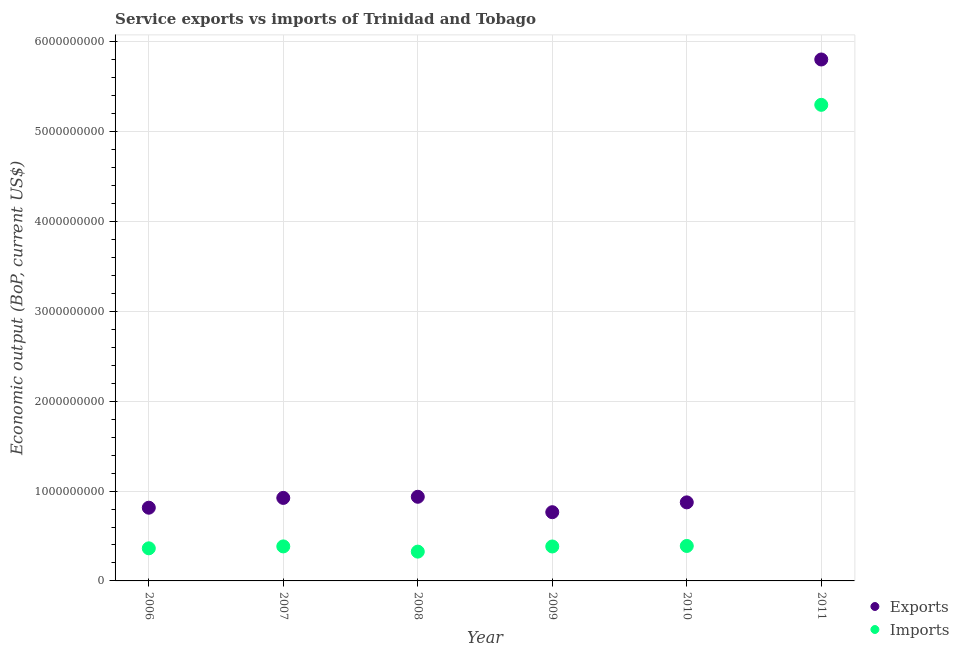How many different coloured dotlines are there?
Give a very brief answer. 2. Is the number of dotlines equal to the number of legend labels?
Provide a short and direct response. Yes. What is the amount of service imports in 2009?
Offer a terse response. 3.83e+08. Across all years, what is the maximum amount of service imports?
Your answer should be compact. 5.30e+09. Across all years, what is the minimum amount of service imports?
Your answer should be compact. 3.26e+08. In which year was the amount of service exports maximum?
Keep it short and to the point. 2011. What is the total amount of service exports in the graph?
Provide a succinct answer. 1.01e+1. What is the difference between the amount of service exports in 2006 and that in 2011?
Offer a terse response. -4.99e+09. What is the difference between the amount of service exports in 2011 and the amount of service imports in 2010?
Ensure brevity in your answer.  5.41e+09. What is the average amount of service exports per year?
Provide a short and direct response. 1.69e+09. In the year 2010, what is the difference between the amount of service imports and amount of service exports?
Your answer should be compact. -4.85e+08. In how many years, is the amount of service exports greater than 5000000000 US$?
Make the answer very short. 1. What is the ratio of the amount of service exports in 2006 to that in 2007?
Offer a very short reply. 0.88. Is the difference between the amount of service exports in 2008 and 2010 greater than the difference between the amount of service imports in 2008 and 2010?
Provide a succinct answer. Yes. What is the difference between the highest and the second highest amount of service exports?
Provide a succinct answer. 4.87e+09. What is the difference between the highest and the lowest amount of service imports?
Your answer should be compact. 4.97e+09. In how many years, is the amount of service imports greater than the average amount of service imports taken over all years?
Your answer should be very brief. 1. Is the sum of the amount of service imports in 2006 and 2008 greater than the maximum amount of service exports across all years?
Your answer should be very brief. No. Does the amount of service exports monotonically increase over the years?
Ensure brevity in your answer.  No. Is the amount of service imports strictly greater than the amount of service exports over the years?
Make the answer very short. No. Is the amount of service imports strictly less than the amount of service exports over the years?
Ensure brevity in your answer.  Yes. How many dotlines are there?
Provide a succinct answer. 2. How many years are there in the graph?
Provide a succinct answer. 6. Does the graph contain any zero values?
Offer a terse response. No. How many legend labels are there?
Your answer should be compact. 2. What is the title of the graph?
Your answer should be very brief. Service exports vs imports of Trinidad and Tobago. What is the label or title of the Y-axis?
Ensure brevity in your answer.  Economic output (BoP, current US$). What is the Economic output (BoP, current US$) in Exports in 2006?
Offer a terse response. 8.15e+08. What is the Economic output (BoP, current US$) in Imports in 2006?
Provide a short and direct response. 3.63e+08. What is the Economic output (BoP, current US$) in Exports in 2007?
Your answer should be compact. 9.24e+08. What is the Economic output (BoP, current US$) of Imports in 2007?
Keep it short and to the point. 3.84e+08. What is the Economic output (BoP, current US$) in Exports in 2008?
Provide a short and direct response. 9.36e+08. What is the Economic output (BoP, current US$) of Imports in 2008?
Ensure brevity in your answer.  3.26e+08. What is the Economic output (BoP, current US$) of Exports in 2009?
Give a very brief answer. 7.65e+08. What is the Economic output (BoP, current US$) of Imports in 2009?
Make the answer very short. 3.83e+08. What is the Economic output (BoP, current US$) in Exports in 2010?
Your answer should be compact. 8.74e+08. What is the Economic output (BoP, current US$) in Imports in 2010?
Your response must be concise. 3.89e+08. What is the Economic output (BoP, current US$) of Exports in 2011?
Make the answer very short. 5.80e+09. What is the Economic output (BoP, current US$) of Imports in 2011?
Offer a terse response. 5.30e+09. Across all years, what is the maximum Economic output (BoP, current US$) in Exports?
Give a very brief answer. 5.80e+09. Across all years, what is the maximum Economic output (BoP, current US$) in Imports?
Your answer should be very brief. 5.30e+09. Across all years, what is the minimum Economic output (BoP, current US$) in Exports?
Your response must be concise. 7.65e+08. Across all years, what is the minimum Economic output (BoP, current US$) in Imports?
Your answer should be compact. 3.26e+08. What is the total Economic output (BoP, current US$) in Exports in the graph?
Your response must be concise. 1.01e+1. What is the total Economic output (BoP, current US$) in Imports in the graph?
Offer a terse response. 7.14e+09. What is the difference between the Economic output (BoP, current US$) in Exports in 2006 and that in 2007?
Make the answer very short. -1.09e+08. What is the difference between the Economic output (BoP, current US$) in Imports in 2006 and that in 2007?
Offer a terse response. -2.13e+07. What is the difference between the Economic output (BoP, current US$) in Exports in 2006 and that in 2008?
Your answer should be very brief. -1.22e+08. What is the difference between the Economic output (BoP, current US$) of Imports in 2006 and that in 2008?
Your answer should be very brief. 3.68e+07. What is the difference between the Economic output (BoP, current US$) in Exports in 2006 and that in 2009?
Ensure brevity in your answer.  5.00e+07. What is the difference between the Economic output (BoP, current US$) of Imports in 2006 and that in 2009?
Your answer should be very brief. -2.05e+07. What is the difference between the Economic output (BoP, current US$) of Exports in 2006 and that in 2010?
Provide a succinct answer. -5.94e+07. What is the difference between the Economic output (BoP, current US$) in Imports in 2006 and that in 2010?
Ensure brevity in your answer.  -2.63e+07. What is the difference between the Economic output (BoP, current US$) of Exports in 2006 and that in 2011?
Give a very brief answer. -4.99e+09. What is the difference between the Economic output (BoP, current US$) in Imports in 2006 and that in 2011?
Ensure brevity in your answer.  -4.94e+09. What is the difference between the Economic output (BoP, current US$) of Exports in 2007 and that in 2008?
Give a very brief answer. -1.27e+07. What is the difference between the Economic output (BoP, current US$) of Imports in 2007 and that in 2008?
Offer a very short reply. 5.81e+07. What is the difference between the Economic output (BoP, current US$) of Exports in 2007 and that in 2009?
Provide a short and direct response. 1.59e+08. What is the difference between the Economic output (BoP, current US$) in Exports in 2007 and that in 2010?
Offer a terse response. 4.96e+07. What is the difference between the Economic output (BoP, current US$) in Imports in 2007 and that in 2010?
Give a very brief answer. -5.00e+06. What is the difference between the Economic output (BoP, current US$) in Exports in 2007 and that in 2011?
Keep it short and to the point. -4.88e+09. What is the difference between the Economic output (BoP, current US$) of Imports in 2007 and that in 2011?
Offer a terse response. -4.91e+09. What is the difference between the Economic output (BoP, current US$) of Exports in 2008 and that in 2009?
Provide a succinct answer. 1.72e+08. What is the difference between the Economic output (BoP, current US$) of Imports in 2008 and that in 2009?
Give a very brief answer. -5.73e+07. What is the difference between the Economic output (BoP, current US$) of Exports in 2008 and that in 2010?
Your answer should be compact. 6.23e+07. What is the difference between the Economic output (BoP, current US$) in Imports in 2008 and that in 2010?
Make the answer very short. -6.31e+07. What is the difference between the Economic output (BoP, current US$) in Exports in 2008 and that in 2011?
Provide a short and direct response. -4.87e+09. What is the difference between the Economic output (BoP, current US$) in Imports in 2008 and that in 2011?
Your response must be concise. -4.97e+09. What is the difference between the Economic output (BoP, current US$) of Exports in 2009 and that in 2010?
Your response must be concise. -1.09e+08. What is the difference between the Economic output (BoP, current US$) of Imports in 2009 and that in 2010?
Make the answer very short. -5.80e+06. What is the difference between the Economic output (BoP, current US$) in Exports in 2009 and that in 2011?
Give a very brief answer. -5.04e+09. What is the difference between the Economic output (BoP, current US$) of Imports in 2009 and that in 2011?
Your answer should be compact. -4.92e+09. What is the difference between the Economic output (BoP, current US$) of Exports in 2010 and that in 2011?
Your response must be concise. -4.93e+09. What is the difference between the Economic output (BoP, current US$) of Imports in 2010 and that in 2011?
Give a very brief answer. -4.91e+09. What is the difference between the Economic output (BoP, current US$) of Exports in 2006 and the Economic output (BoP, current US$) of Imports in 2007?
Provide a short and direct response. 4.31e+08. What is the difference between the Economic output (BoP, current US$) in Exports in 2006 and the Economic output (BoP, current US$) in Imports in 2008?
Provide a short and direct response. 4.89e+08. What is the difference between the Economic output (BoP, current US$) of Exports in 2006 and the Economic output (BoP, current US$) of Imports in 2009?
Your answer should be compact. 4.32e+08. What is the difference between the Economic output (BoP, current US$) in Exports in 2006 and the Economic output (BoP, current US$) in Imports in 2010?
Your response must be concise. 4.26e+08. What is the difference between the Economic output (BoP, current US$) in Exports in 2006 and the Economic output (BoP, current US$) in Imports in 2011?
Offer a very short reply. -4.48e+09. What is the difference between the Economic output (BoP, current US$) of Exports in 2007 and the Economic output (BoP, current US$) of Imports in 2008?
Offer a terse response. 5.98e+08. What is the difference between the Economic output (BoP, current US$) in Exports in 2007 and the Economic output (BoP, current US$) in Imports in 2009?
Your answer should be very brief. 5.40e+08. What is the difference between the Economic output (BoP, current US$) of Exports in 2007 and the Economic output (BoP, current US$) of Imports in 2010?
Keep it short and to the point. 5.35e+08. What is the difference between the Economic output (BoP, current US$) in Exports in 2007 and the Economic output (BoP, current US$) in Imports in 2011?
Offer a terse response. -4.37e+09. What is the difference between the Economic output (BoP, current US$) of Exports in 2008 and the Economic output (BoP, current US$) of Imports in 2009?
Offer a terse response. 5.53e+08. What is the difference between the Economic output (BoP, current US$) of Exports in 2008 and the Economic output (BoP, current US$) of Imports in 2010?
Make the answer very short. 5.47e+08. What is the difference between the Economic output (BoP, current US$) in Exports in 2008 and the Economic output (BoP, current US$) in Imports in 2011?
Ensure brevity in your answer.  -4.36e+09. What is the difference between the Economic output (BoP, current US$) of Exports in 2009 and the Economic output (BoP, current US$) of Imports in 2010?
Your answer should be very brief. 3.76e+08. What is the difference between the Economic output (BoP, current US$) of Exports in 2009 and the Economic output (BoP, current US$) of Imports in 2011?
Keep it short and to the point. -4.53e+09. What is the difference between the Economic output (BoP, current US$) in Exports in 2010 and the Economic output (BoP, current US$) in Imports in 2011?
Keep it short and to the point. -4.42e+09. What is the average Economic output (BoP, current US$) of Exports per year?
Your answer should be compact. 1.69e+09. What is the average Economic output (BoP, current US$) in Imports per year?
Keep it short and to the point. 1.19e+09. In the year 2006, what is the difference between the Economic output (BoP, current US$) of Exports and Economic output (BoP, current US$) of Imports?
Offer a terse response. 4.52e+08. In the year 2007, what is the difference between the Economic output (BoP, current US$) in Exports and Economic output (BoP, current US$) in Imports?
Give a very brief answer. 5.40e+08. In the year 2008, what is the difference between the Economic output (BoP, current US$) in Exports and Economic output (BoP, current US$) in Imports?
Offer a very short reply. 6.10e+08. In the year 2009, what is the difference between the Economic output (BoP, current US$) of Exports and Economic output (BoP, current US$) of Imports?
Ensure brevity in your answer.  3.82e+08. In the year 2010, what is the difference between the Economic output (BoP, current US$) of Exports and Economic output (BoP, current US$) of Imports?
Provide a short and direct response. 4.85e+08. In the year 2011, what is the difference between the Economic output (BoP, current US$) of Exports and Economic output (BoP, current US$) of Imports?
Ensure brevity in your answer.  5.05e+08. What is the ratio of the Economic output (BoP, current US$) in Exports in 2006 to that in 2007?
Your answer should be very brief. 0.88. What is the ratio of the Economic output (BoP, current US$) in Imports in 2006 to that in 2007?
Make the answer very short. 0.94. What is the ratio of the Economic output (BoP, current US$) of Exports in 2006 to that in 2008?
Your answer should be compact. 0.87. What is the ratio of the Economic output (BoP, current US$) in Imports in 2006 to that in 2008?
Make the answer very short. 1.11. What is the ratio of the Economic output (BoP, current US$) in Exports in 2006 to that in 2009?
Keep it short and to the point. 1.07. What is the ratio of the Economic output (BoP, current US$) of Imports in 2006 to that in 2009?
Your answer should be compact. 0.95. What is the ratio of the Economic output (BoP, current US$) of Exports in 2006 to that in 2010?
Give a very brief answer. 0.93. What is the ratio of the Economic output (BoP, current US$) of Imports in 2006 to that in 2010?
Offer a very short reply. 0.93. What is the ratio of the Economic output (BoP, current US$) in Exports in 2006 to that in 2011?
Your answer should be very brief. 0.14. What is the ratio of the Economic output (BoP, current US$) in Imports in 2006 to that in 2011?
Your answer should be very brief. 0.07. What is the ratio of the Economic output (BoP, current US$) of Exports in 2007 to that in 2008?
Keep it short and to the point. 0.99. What is the ratio of the Economic output (BoP, current US$) in Imports in 2007 to that in 2008?
Your response must be concise. 1.18. What is the ratio of the Economic output (BoP, current US$) of Exports in 2007 to that in 2009?
Make the answer very short. 1.21. What is the ratio of the Economic output (BoP, current US$) in Imports in 2007 to that in 2009?
Your response must be concise. 1. What is the ratio of the Economic output (BoP, current US$) of Exports in 2007 to that in 2010?
Your answer should be compact. 1.06. What is the ratio of the Economic output (BoP, current US$) of Imports in 2007 to that in 2010?
Your answer should be compact. 0.99. What is the ratio of the Economic output (BoP, current US$) in Exports in 2007 to that in 2011?
Your answer should be very brief. 0.16. What is the ratio of the Economic output (BoP, current US$) of Imports in 2007 to that in 2011?
Your answer should be very brief. 0.07. What is the ratio of the Economic output (BoP, current US$) of Exports in 2008 to that in 2009?
Your answer should be very brief. 1.22. What is the ratio of the Economic output (BoP, current US$) of Imports in 2008 to that in 2009?
Your response must be concise. 0.85. What is the ratio of the Economic output (BoP, current US$) of Exports in 2008 to that in 2010?
Offer a very short reply. 1.07. What is the ratio of the Economic output (BoP, current US$) of Imports in 2008 to that in 2010?
Your answer should be compact. 0.84. What is the ratio of the Economic output (BoP, current US$) in Exports in 2008 to that in 2011?
Give a very brief answer. 0.16. What is the ratio of the Economic output (BoP, current US$) of Imports in 2008 to that in 2011?
Give a very brief answer. 0.06. What is the ratio of the Economic output (BoP, current US$) of Exports in 2009 to that in 2010?
Your answer should be very brief. 0.87. What is the ratio of the Economic output (BoP, current US$) in Imports in 2009 to that in 2010?
Ensure brevity in your answer.  0.99. What is the ratio of the Economic output (BoP, current US$) in Exports in 2009 to that in 2011?
Offer a terse response. 0.13. What is the ratio of the Economic output (BoP, current US$) in Imports in 2009 to that in 2011?
Provide a short and direct response. 0.07. What is the ratio of the Economic output (BoP, current US$) in Exports in 2010 to that in 2011?
Ensure brevity in your answer.  0.15. What is the ratio of the Economic output (BoP, current US$) in Imports in 2010 to that in 2011?
Provide a short and direct response. 0.07. What is the difference between the highest and the second highest Economic output (BoP, current US$) in Exports?
Provide a succinct answer. 4.87e+09. What is the difference between the highest and the second highest Economic output (BoP, current US$) in Imports?
Keep it short and to the point. 4.91e+09. What is the difference between the highest and the lowest Economic output (BoP, current US$) of Exports?
Your response must be concise. 5.04e+09. What is the difference between the highest and the lowest Economic output (BoP, current US$) of Imports?
Give a very brief answer. 4.97e+09. 